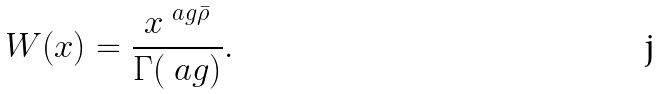Convert formula to latex. <formula><loc_0><loc_0><loc_500><loc_500>W ( x ) = \frac { x ^ { \ a g \bar { \rho } } } { \Gamma ( \ a g ) } .</formula> 